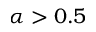Convert formula to latex. <formula><loc_0><loc_0><loc_500><loc_500>\alpha > 0 . 5</formula> 